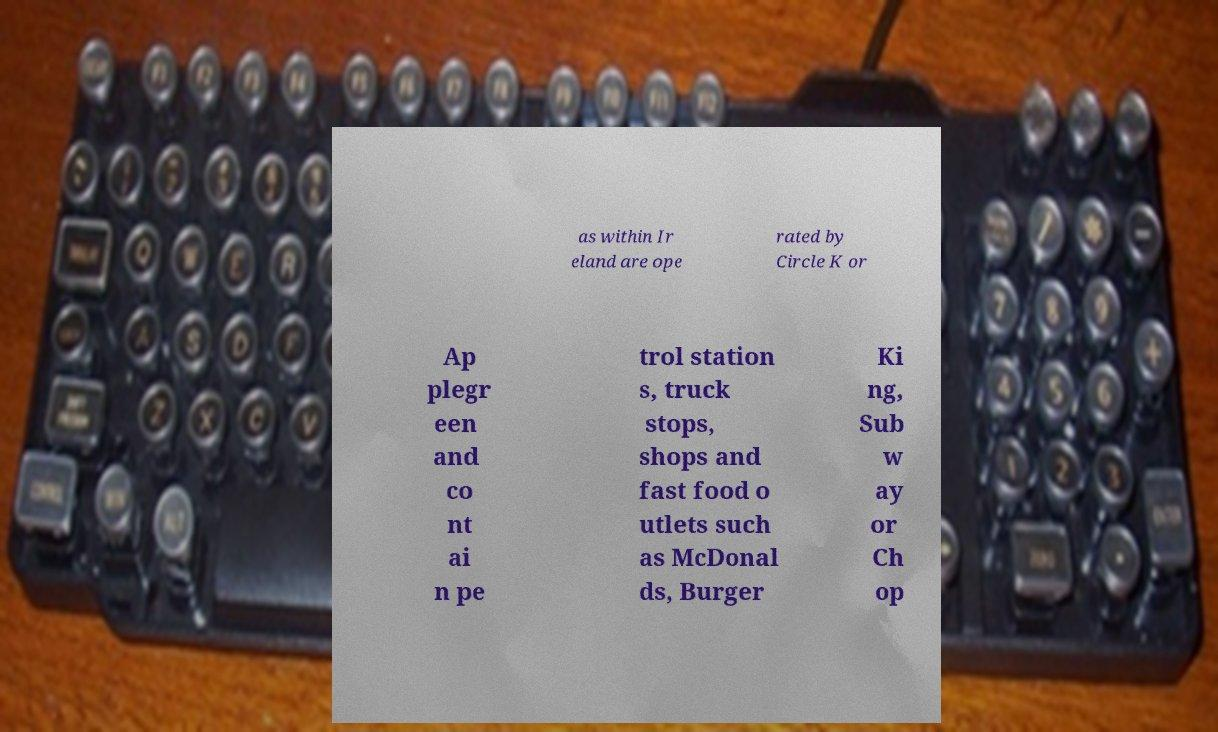Please read and relay the text visible in this image. What does it say? as within Ir eland are ope rated by Circle K or Ap plegr een and co nt ai n pe trol station s, truck stops, shops and fast food o utlets such as McDonal ds, Burger Ki ng, Sub w ay or Ch op 